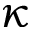Convert formula to latex. <formula><loc_0><loc_0><loc_500><loc_500>\kappa</formula> 